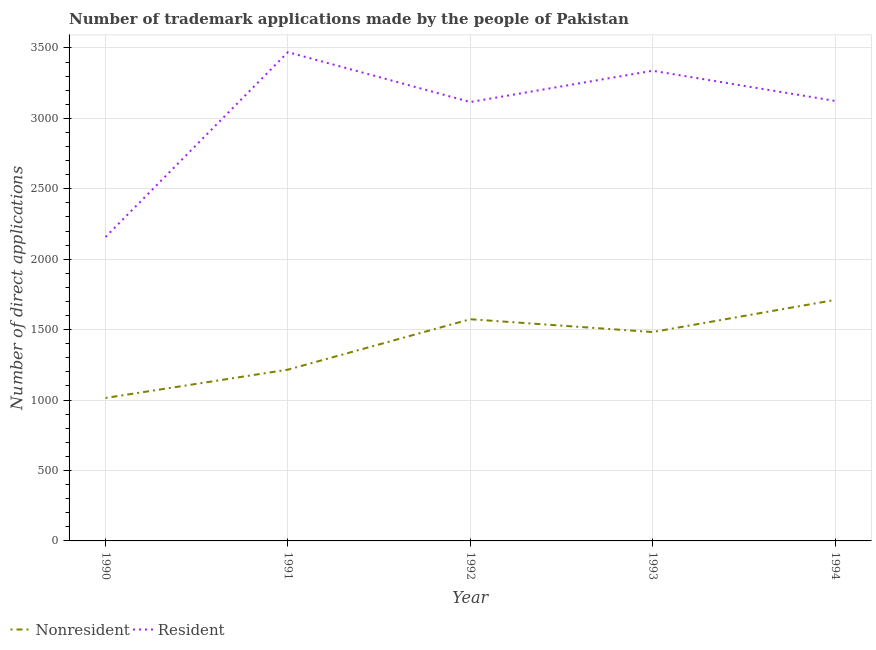How many different coloured lines are there?
Your response must be concise. 2. Is the number of lines equal to the number of legend labels?
Your response must be concise. Yes. What is the number of trademark applications made by residents in 1990?
Offer a terse response. 2158. Across all years, what is the maximum number of trademark applications made by residents?
Your answer should be very brief. 3470. Across all years, what is the minimum number of trademark applications made by non residents?
Your answer should be very brief. 1015. In which year was the number of trademark applications made by residents maximum?
Your answer should be very brief. 1991. What is the total number of trademark applications made by residents in the graph?
Offer a terse response. 1.52e+04. What is the difference between the number of trademark applications made by residents in 1993 and that in 1994?
Make the answer very short. 214. What is the difference between the number of trademark applications made by residents in 1993 and the number of trademark applications made by non residents in 1994?
Your answer should be very brief. 1627. What is the average number of trademark applications made by residents per year?
Provide a short and direct response. 3041.2. In the year 1993, what is the difference between the number of trademark applications made by residents and number of trademark applications made by non residents?
Provide a short and direct response. 1855. In how many years, is the number of trademark applications made by non residents greater than 2300?
Offer a very short reply. 0. What is the ratio of the number of trademark applications made by residents in 1990 to that in 1993?
Offer a very short reply. 0.65. Is the number of trademark applications made by residents in 1992 less than that in 1994?
Make the answer very short. Yes. What is the difference between the highest and the second highest number of trademark applications made by non residents?
Provide a short and direct response. 137. What is the difference between the highest and the lowest number of trademark applications made by residents?
Your response must be concise. 1312. In how many years, is the number of trademark applications made by non residents greater than the average number of trademark applications made by non residents taken over all years?
Give a very brief answer. 3. Is the sum of the number of trademark applications made by residents in 1991 and 1994 greater than the maximum number of trademark applications made by non residents across all years?
Provide a short and direct response. Yes. Does the number of trademark applications made by residents monotonically increase over the years?
Provide a succinct answer. No. Is the number of trademark applications made by non residents strictly greater than the number of trademark applications made by residents over the years?
Offer a very short reply. No. How many lines are there?
Your response must be concise. 2. How many years are there in the graph?
Keep it short and to the point. 5. Does the graph contain grids?
Your response must be concise. Yes. How many legend labels are there?
Ensure brevity in your answer.  2. How are the legend labels stacked?
Make the answer very short. Horizontal. What is the title of the graph?
Give a very brief answer. Number of trademark applications made by the people of Pakistan. What is the label or title of the Y-axis?
Make the answer very short. Number of direct applications. What is the Number of direct applications of Nonresident in 1990?
Keep it short and to the point. 1015. What is the Number of direct applications in Resident in 1990?
Offer a terse response. 2158. What is the Number of direct applications in Nonresident in 1991?
Keep it short and to the point. 1216. What is the Number of direct applications of Resident in 1991?
Your answer should be compact. 3470. What is the Number of direct applications in Nonresident in 1992?
Provide a succinct answer. 1574. What is the Number of direct applications of Resident in 1992?
Offer a terse response. 3116. What is the Number of direct applications in Nonresident in 1993?
Offer a very short reply. 1483. What is the Number of direct applications of Resident in 1993?
Make the answer very short. 3338. What is the Number of direct applications of Nonresident in 1994?
Give a very brief answer. 1711. What is the Number of direct applications in Resident in 1994?
Provide a succinct answer. 3124. Across all years, what is the maximum Number of direct applications in Nonresident?
Make the answer very short. 1711. Across all years, what is the maximum Number of direct applications of Resident?
Offer a terse response. 3470. Across all years, what is the minimum Number of direct applications in Nonresident?
Give a very brief answer. 1015. Across all years, what is the minimum Number of direct applications in Resident?
Your response must be concise. 2158. What is the total Number of direct applications of Nonresident in the graph?
Ensure brevity in your answer.  6999. What is the total Number of direct applications in Resident in the graph?
Make the answer very short. 1.52e+04. What is the difference between the Number of direct applications in Nonresident in 1990 and that in 1991?
Offer a very short reply. -201. What is the difference between the Number of direct applications in Resident in 1990 and that in 1991?
Your response must be concise. -1312. What is the difference between the Number of direct applications of Nonresident in 1990 and that in 1992?
Give a very brief answer. -559. What is the difference between the Number of direct applications in Resident in 1990 and that in 1992?
Provide a succinct answer. -958. What is the difference between the Number of direct applications in Nonresident in 1990 and that in 1993?
Ensure brevity in your answer.  -468. What is the difference between the Number of direct applications in Resident in 1990 and that in 1993?
Your response must be concise. -1180. What is the difference between the Number of direct applications of Nonresident in 1990 and that in 1994?
Ensure brevity in your answer.  -696. What is the difference between the Number of direct applications in Resident in 1990 and that in 1994?
Provide a short and direct response. -966. What is the difference between the Number of direct applications in Nonresident in 1991 and that in 1992?
Provide a succinct answer. -358. What is the difference between the Number of direct applications of Resident in 1991 and that in 1992?
Offer a terse response. 354. What is the difference between the Number of direct applications of Nonresident in 1991 and that in 1993?
Offer a very short reply. -267. What is the difference between the Number of direct applications in Resident in 1991 and that in 1993?
Provide a short and direct response. 132. What is the difference between the Number of direct applications of Nonresident in 1991 and that in 1994?
Give a very brief answer. -495. What is the difference between the Number of direct applications in Resident in 1991 and that in 1994?
Keep it short and to the point. 346. What is the difference between the Number of direct applications in Nonresident in 1992 and that in 1993?
Your response must be concise. 91. What is the difference between the Number of direct applications of Resident in 1992 and that in 1993?
Provide a short and direct response. -222. What is the difference between the Number of direct applications in Nonresident in 1992 and that in 1994?
Your response must be concise. -137. What is the difference between the Number of direct applications in Nonresident in 1993 and that in 1994?
Offer a very short reply. -228. What is the difference between the Number of direct applications of Resident in 1993 and that in 1994?
Your answer should be very brief. 214. What is the difference between the Number of direct applications of Nonresident in 1990 and the Number of direct applications of Resident in 1991?
Make the answer very short. -2455. What is the difference between the Number of direct applications of Nonresident in 1990 and the Number of direct applications of Resident in 1992?
Make the answer very short. -2101. What is the difference between the Number of direct applications of Nonresident in 1990 and the Number of direct applications of Resident in 1993?
Your answer should be very brief. -2323. What is the difference between the Number of direct applications in Nonresident in 1990 and the Number of direct applications in Resident in 1994?
Offer a very short reply. -2109. What is the difference between the Number of direct applications of Nonresident in 1991 and the Number of direct applications of Resident in 1992?
Provide a short and direct response. -1900. What is the difference between the Number of direct applications in Nonresident in 1991 and the Number of direct applications in Resident in 1993?
Your answer should be very brief. -2122. What is the difference between the Number of direct applications of Nonresident in 1991 and the Number of direct applications of Resident in 1994?
Give a very brief answer. -1908. What is the difference between the Number of direct applications of Nonresident in 1992 and the Number of direct applications of Resident in 1993?
Provide a succinct answer. -1764. What is the difference between the Number of direct applications in Nonresident in 1992 and the Number of direct applications in Resident in 1994?
Provide a short and direct response. -1550. What is the difference between the Number of direct applications in Nonresident in 1993 and the Number of direct applications in Resident in 1994?
Ensure brevity in your answer.  -1641. What is the average Number of direct applications in Nonresident per year?
Provide a succinct answer. 1399.8. What is the average Number of direct applications in Resident per year?
Offer a very short reply. 3041.2. In the year 1990, what is the difference between the Number of direct applications of Nonresident and Number of direct applications of Resident?
Provide a succinct answer. -1143. In the year 1991, what is the difference between the Number of direct applications of Nonresident and Number of direct applications of Resident?
Offer a terse response. -2254. In the year 1992, what is the difference between the Number of direct applications of Nonresident and Number of direct applications of Resident?
Provide a succinct answer. -1542. In the year 1993, what is the difference between the Number of direct applications in Nonresident and Number of direct applications in Resident?
Give a very brief answer. -1855. In the year 1994, what is the difference between the Number of direct applications in Nonresident and Number of direct applications in Resident?
Your response must be concise. -1413. What is the ratio of the Number of direct applications of Nonresident in 1990 to that in 1991?
Provide a short and direct response. 0.83. What is the ratio of the Number of direct applications in Resident in 1990 to that in 1991?
Keep it short and to the point. 0.62. What is the ratio of the Number of direct applications of Nonresident in 1990 to that in 1992?
Make the answer very short. 0.64. What is the ratio of the Number of direct applications in Resident in 1990 to that in 1992?
Offer a terse response. 0.69. What is the ratio of the Number of direct applications of Nonresident in 1990 to that in 1993?
Offer a terse response. 0.68. What is the ratio of the Number of direct applications in Resident in 1990 to that in 1993?
Your answer should be compact. 0.65. What is the ratio of the Number of direct applications of Nonresident in 1990 to that in 1994?
Your response must be concise. 0.59. What is the ratio of the Number of direct applications in Resident in 1990 to that in 1994?
Give a very brief answer. 0.69. What is the ratio of the Number of direct applications of Nonresident in 1991 to that in 1992?
Your answer should be compact. 0.77. What is the ratio of the Number of direct applications in Resident in 1991 to that in 1992?
Your response must be concise. 1.11. What is the ratio of the Number of direct applications in Nonresident in 1991 to that in 1993?
Offer a terse response. 0.82. What is the ratio of the Number of direct applications in Resident in 1991 to that in 1993?
Provide a succinct answer. 1.04. What is the ratio of the Number of direct applications of Nonresident in 1991 to that in 1994?
Your answer should be compact. 0.71. What is the ratio of the Number of direct applications of Resident in 1991 to that in 1994?
Make the answer very short. 1.11. What is the ratio of the Number of direct applications of Nonresident in 1992 to that in 1993?
Make the answer very short. 1.06. What is the ratio of the Number of direct applications in Resident in 1992 to that in 1993?
Your answer should be compact. 0.93. What is the ratio of the Number of direct applications of Nonresident in 1992 to that in 1994?
Offer a very short reply. 0.92. What is the ratio of the Number of direct applications of Resident in 1992 to that in 1994?
Ensure brevity in your answer.  1. What is the ratio of the Number of direct applications of Nonresident in 1993 to that in 1994?
Offer a terse response. 0.87. What is the ratio of the Number of direct applications of Resident in 1993 to that in 1994?
Offer a terse response. 1.07. What is the difference between the highest and the second highest Number of direct applications of Nonresident?
Your response must be concise. 137. What is the difference between the highest and the second highest Number of direct applications of Resident?
Offer a terse response. 132. What is the difference between the highest and the lowest Number of direct applications of Nonresident?
Provide a succinct answer. 696. What is the difference between the highest and the lowest Number of direct applications of Resident?
Provide a succinct answer. 1312. 